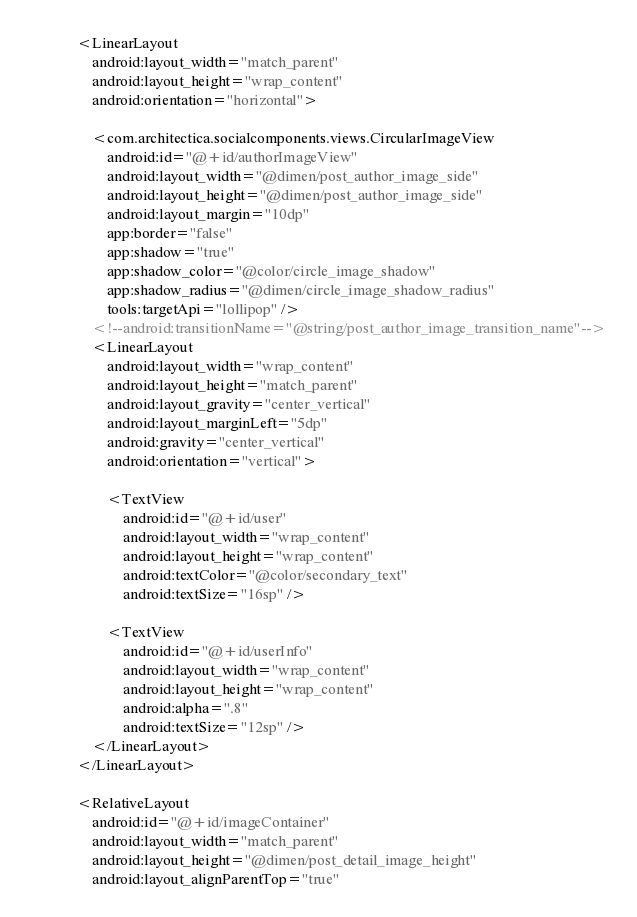<code> <loc_0><loc_0><loc_500><loc_500><_XML_>
            <LinearLayout
                android:layout_width="match_parent"
                android:layout_height="wrap_content"
                android:orientation="horizontal">

                <com.architectica.socialcomponents.views.CircularImageView
                    android:id="@+id/authorImageView"
                    android:layout_width="@dimen/post_author_image_side"
                    android:layout_height="@dimen/post_author_image_side"
                    android:layout_margin="10dp"
                    app:border="false"
                    app:shadow="true"
                    app:shadow_color="@color/circle_image_shadow"
                    app:shadow_radius="@dimen/circle_image_shadow_radius"
                    tools:targetApi="lollipop" />
                <!--android:transitionName="@string/post_author_image_transition_name"-->
                <LinearLayout
                    android:layout_width="wrap_content"
                    android:layout_height="match_parent"
                    android:layout_gravity="center_vertical"
                    android:layout_marginLeft="5dp"
                    android:gravity="center_vertical"
                    android:orientation="vertical">

                    <TextView
                        android:id="@+id/user"
                        android:layout_width="wrap_content"
                        android:layout_height="wrap_content"
                        android:textColor="@color/secondary_text"
                        android:textSize="16sp" />

                    <TextView
                        android:id="@+id/userInfo"
                        android:layout_width="wrap_content"
                        android:layout_height="wrap_content"
                        android:alpha=".8"
                        android:textSize="12sp" />
                </LinearLayout>
            </LinearLayout>

            <RelativeLayout
                android:id="@+id/imageContainer"
                android:layout_width="match_parent"
                android:layout_height="@dimen/post_detail_image_height"
                android:layout_alignParentTop="true"</code> 